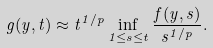<formula> <loc_0><loc_0><loc_500><loc_500>g ( y , t ) \approx t ^ { 1 / p } \inf _ { 1 \leq s \leq t } \frac { f ( y , s ) } { s ^ { 1 / p } } .</formula> 